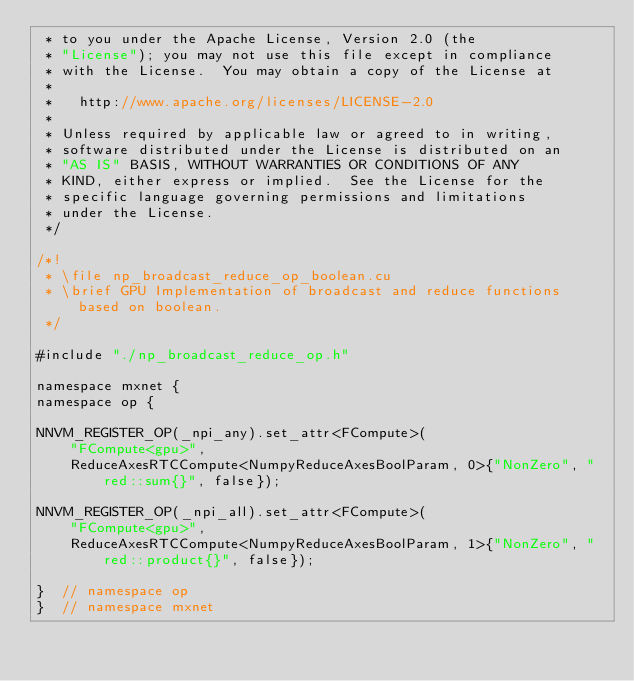<code> <loc_0><loc_0><loc_500><loc_500><_Cuda_> * to you under the Apache License, Version 2.0 (the
 * "License"); you may not use this file except in compliance
 * with the License.  You may obtain a copy of the License at
 *
 *   http://www.apache.org/licenses/LICENSE-2.0
 *
 * Unless required by applicable law or agreed to in writing,
 * software distributed under the License is distributed on an
 * "AS IS" BASIS, WITHOUT WARRANTIES OR CONDITIONS OF ANY
 * KIND, either express or implied.  See the License for the
 * specific language governing permissions and limitations
 * under the License.
 */

/*!
 * \file np_broadcast_reduce_op_boolean.cu
 * \brief GPU Implementation of broadcast and reduce functions based on boolean.
 */

#include "./np_broadcast_reduce_op.h"

namespace mxnet {
namespace op {

NNVM_REGISTER_OP(_npi_any).set_attr<FCompute>(
    "FCompute<gpu>",
    ReduceAxesRTCCompute<NumpyReduceAxesBoolParam, 0>{"NonZero", "red::sum{}", false});

NNVM_REGISTER_OP(_npi_all).set_attr<FCompute>(
    "FCompute<gpu>",
    ReduceAxesRTCCompute<NumpyReduceAxesBoolParam, 1>{"NonZero", "red::product{}", false});

}  // namespace op
}  // namespace mxnet
</code> 